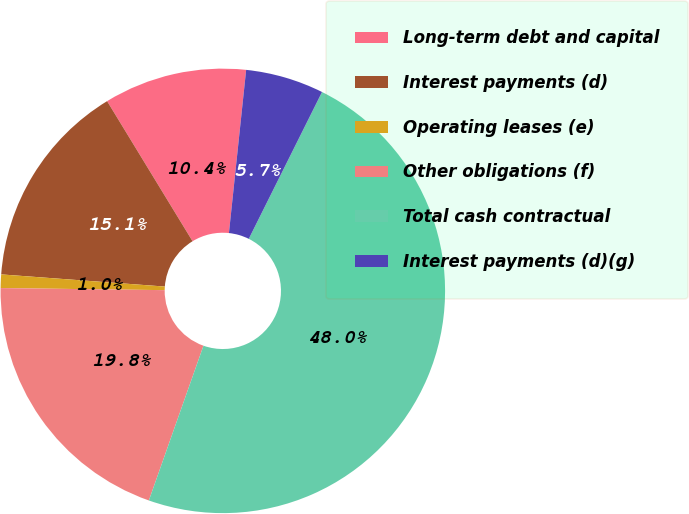<chart> <loc_0><loc_0><loc_500><loc_500><pie_chart><fcel>Long-term debt and capital<fcel>Interest payments (d)<fcel>Operating leases (e)<fcel>Other obligations (f)<fcel>Total cash contractual<fcel>Interest payments (d)(g)<nl><fcel>10.39%<fcel>15.1%<fcel>0.98%<fcel>19.8%<fcel>48.03%<fcel>5.69%<nl></chart> 